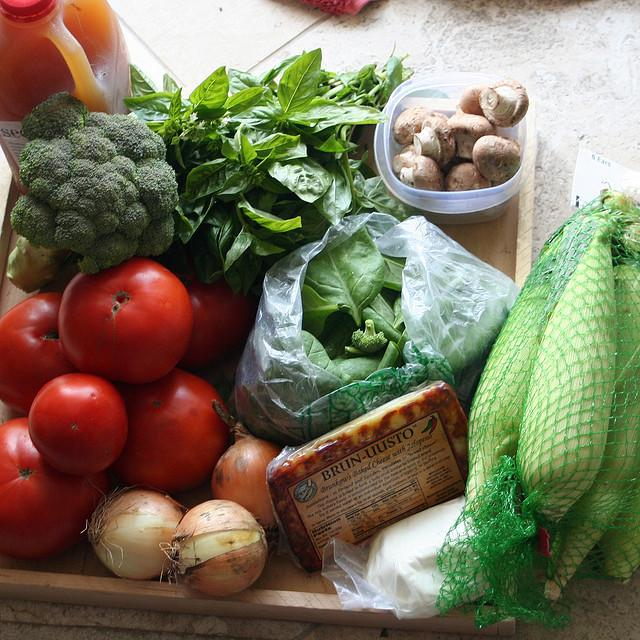What category of food is this? Please explain your reasoning. vegetables. Tomatoes, corn, onions, mushrooms, and broccoli are on a table. 